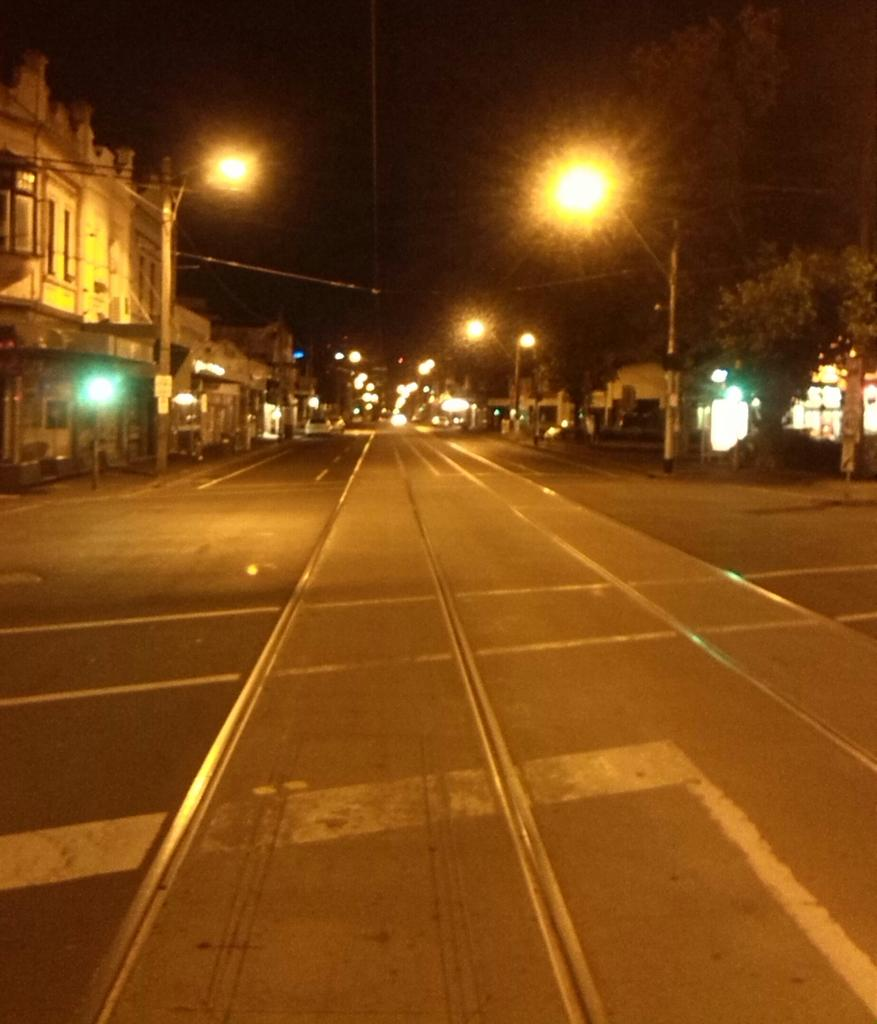What structures can be seen in the image? There are poles, lights, a road, trees, and buildings in the image. What is the primary purpose of the poles in the image? The poles in the image likely support the lights. What is the condition of the sky in the image? The image was taken during night time, so the sky is not visible. What type of vegetation is present in the image? There are trees in the image. Can you see a board with a cat on it in the image? There is no board or cat present in the image. What color is the sky above the buildings in the image? The image was taken during night time, so the sky is not visible in the image. 